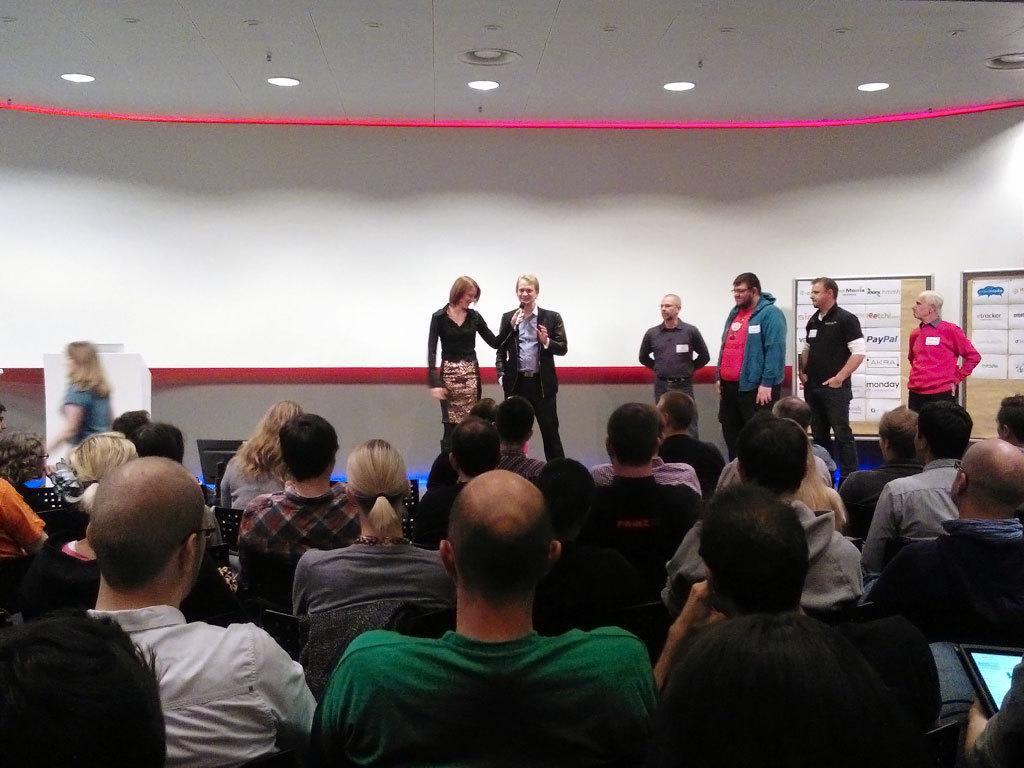Can you describe this image briefly? There are group of people sitting on the chairs. I can see few people standing. These are the ceiling lights, which are attached to the roof. I can see papers attached to the wooden boards. 